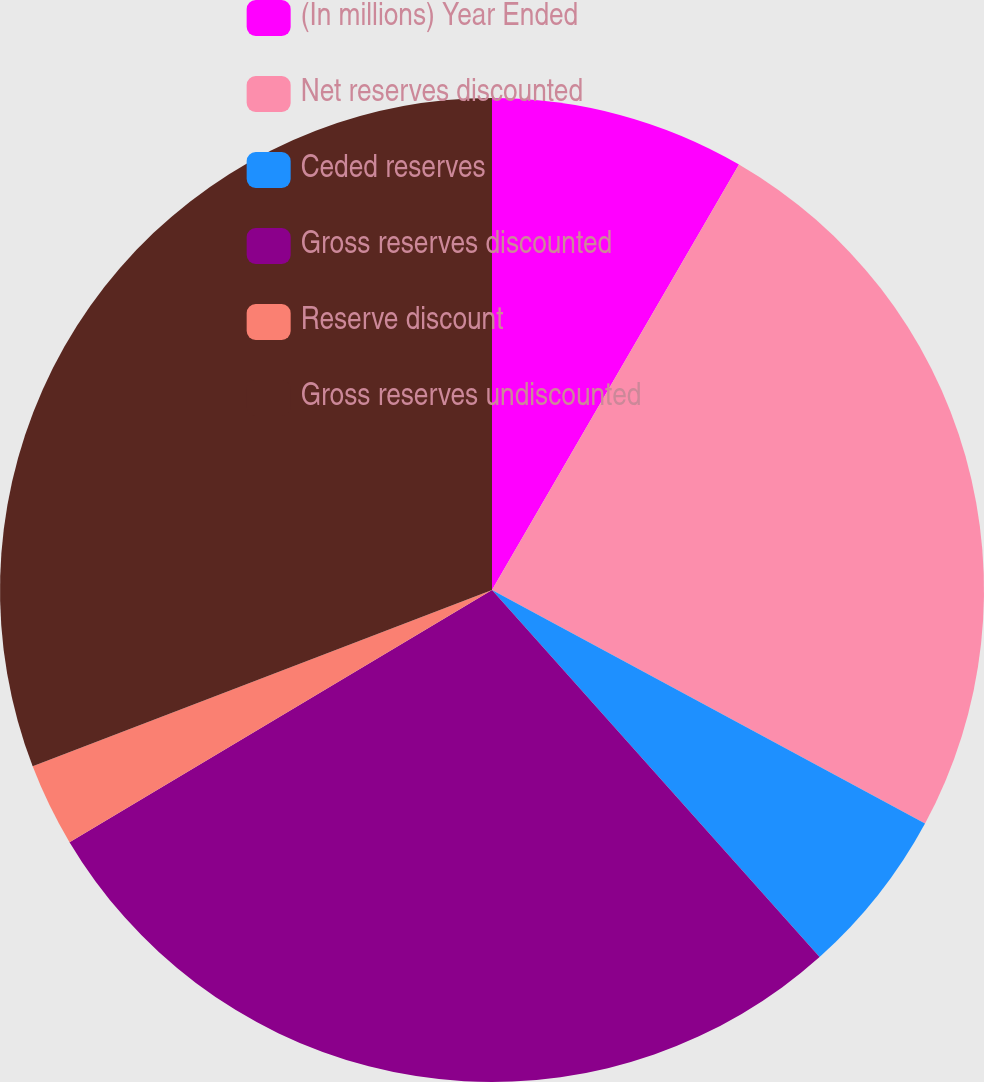<chart> <loc_0><loc_0><loc_500><loc_500><pie_chart><fcel>(In millions) Year Ended<fcel>Net reserves discounted<fcel>Ceded reserves<fcel>Gross reserves discounted<fcel>Reserve discount<fcel>Gross reserves undiscounted<nl><fcel>8.37%<fcel>24.5%<fcel>5.53%<fcel>28.03%<fcel>2.73%<fcel>30.83%<nl></chart> 